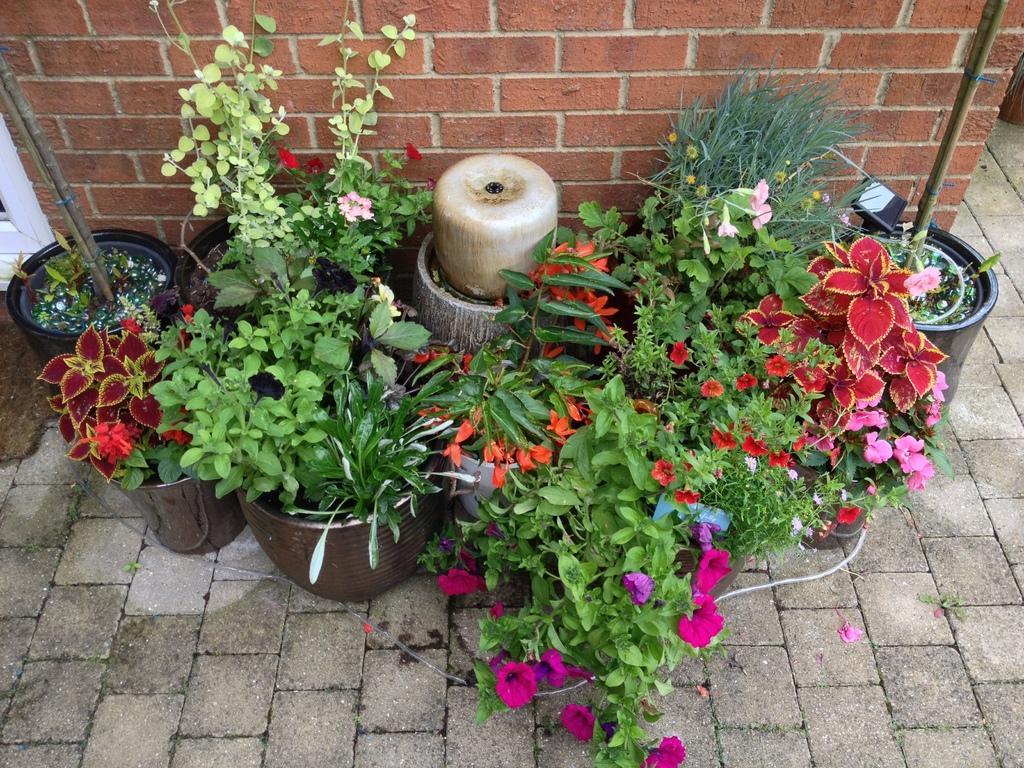How would you summarize this image in a sentence or two? In this picture we can see so many potted plants are placed beside the wall. 